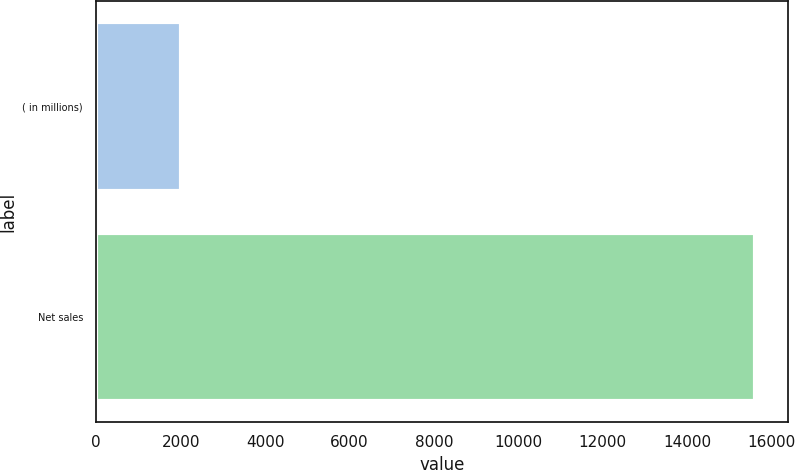Convert chart. <chart><loc_0><loc_0><loc_500><loc_500><bar_chart><fcel>( in millions)<fcel>Net sales<nl><fcel>2014<fcel>15606<nl></chart> 